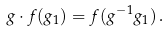<formula> <loc_0><loc_0><loc_500><loc_500>g \cdot f ( g _ { 1 } ) = f ( g ^ { - 1 } g _ { 1 } ) \, .</formula> 